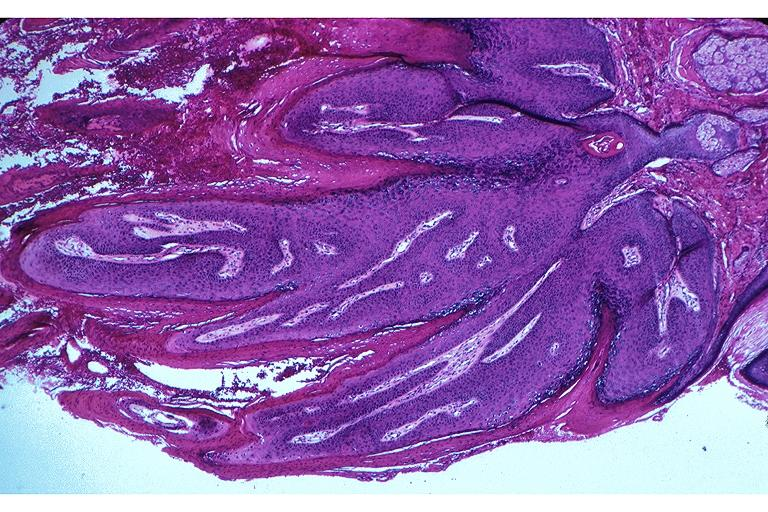where is this?
Answer the question using a single word or phrase. Oral 